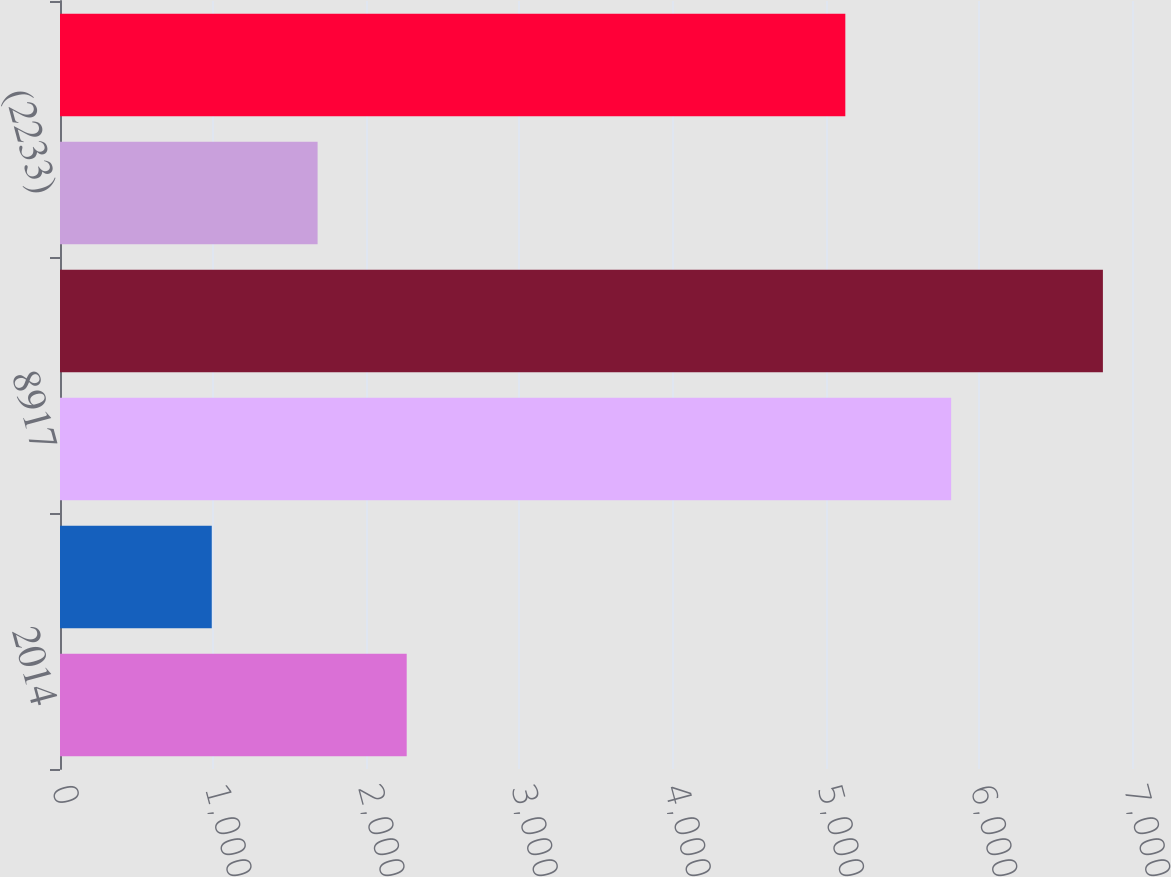Convert chart to OTSL. <chart><loc_0><loc_0><loc_500><loc_500><bar_chart><fcel>2014<fcel>1753<fcel>8917<fcel>10670<fcel>(2233)<fcel>8437<nl><fcel>2263.9<fcel>991<fcel>5819<fcel>6810<fcel>1682<fcel>5128<nl></chart> 